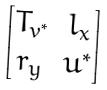Convert formula to latex. <formula><loc_0><loc_0><loc_500><loc_500>\begin{bmatrix} T _ { v ^ { * } } & l _ { x } \\ r _ { y } & u ^ { * } \\ \end{bmatrix}</formula> 